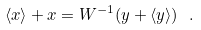<formula> <loc_0><loc_0><loc_500><loc_500>\langle { x } \rangle + { x } = { W } ^ { - 1 } ( { y } + \langle { y } \rangle ) \ .</formula> 